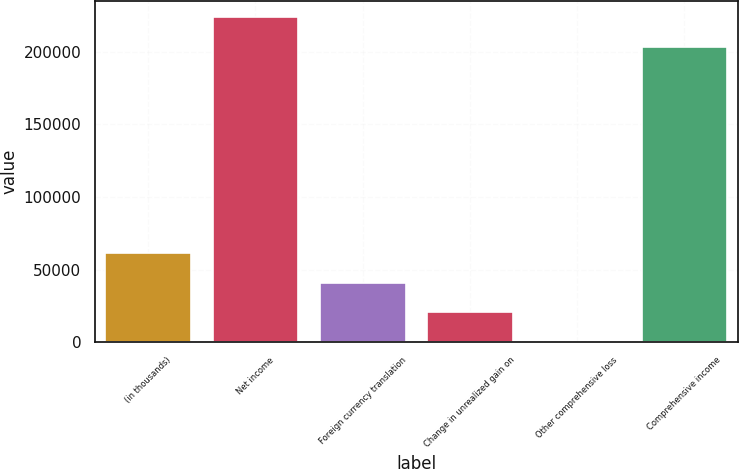Convert chart. <chart><loc_0><loc_0><loc_500><loc_500><bar_chart><fcel>(in thousands)<fcel>Net income<fcel>Foreign currency translation<fcel>Change in unrealized gain on<fcel>Other comprehensive loss<fcel>Comprehensive income<nl><fcel>61463.4<fcel>223969<fcel>41102.6<fcel>20741.8<fcel>381<fcel>203608<nl></chart> 